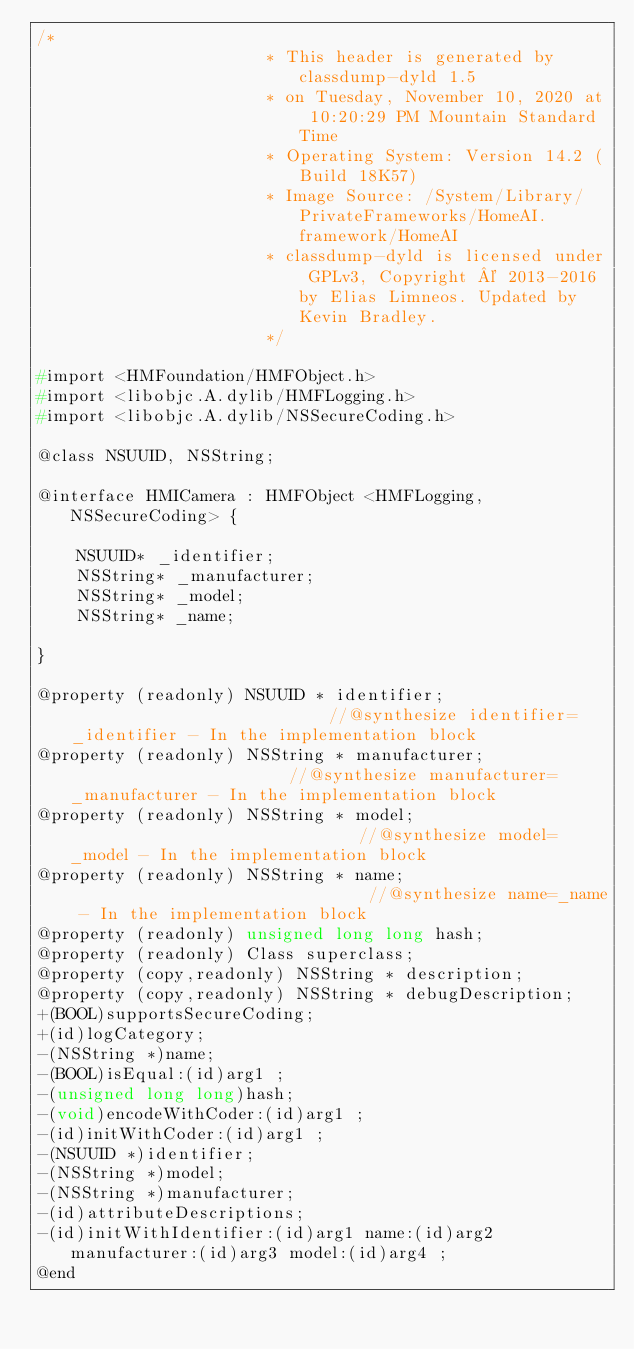<code> <loc_0><loc_0><loc_500><loc_500><_C_>/*
                       * This header is generated by classdump-dyld 1.5
                       * on Tuesday, November 10, 2020 at 10:20:29 PM Mountain Standard Time
                       * Operating System: Version 14.2 (Build 18K57)
                       * Image Source: /System/Library/PrivateFrameworks/HomeAI.framework/HomeAI
                       * classdump-dyld is licensed under GPLv3, Copyright © 2013-2016 by Elias Limneos. Updated by Kevin Bradley.
                       */

#import <HMFoundation/HMFObject.h>
#import <libobjc.A.dylib/HMFLogging.h>
#import <libobjc.A.dylib/NSSecureCoding.h>

@class NSUUID, NSString;

@interface HMICamera : HMFObject <HMFLogging, NSSecureCoding> {

	NSUUID* _identifier;
	NSString* _manufacturer;
	NSString* _model;
	NSString* _name;

}

@property (readonly) NSUUID * identifier;                           //@synthesize identifier=_identifier - In the implementation block
@property (readonly) NSString * manufacturer;                       //@synthesize manufacturer=_manufacturer - In the implementation block
@property (readonly) NSString * model;                              //@synthesize model=_model - In the implementation block
@property (readonly) NSString * name;                               //@synthesize name=_name - In the implementation block
@property (readonly) unsigned long long hash; 
@property (readonly) Class superclass; 
@property (copy,readonly) NSString * description; 
@property (copy,readonly) NSString * debugDescription; 
+(BOOL)supportsSecureCoding;
+(id)logCategory;
-(NSString *)name;
-(BOOL)isEqual:(id)arg1 ;
-(unsigned long long)hash;
-(void)encodeWithCoder:(id)arg1 ;
-(id)initWithCoder:(id)arg1 ;
-(NSUUID *)identifier;
-(NSString *)model;
-(NSString *)manufacturer;
-(id)attributeDescriptions;
-(id)initWithIdentifier:(id)arg1 name:(id)arg2 manufacturer:(id)arg3 model:(id)arg4 ;
@end

</code> 